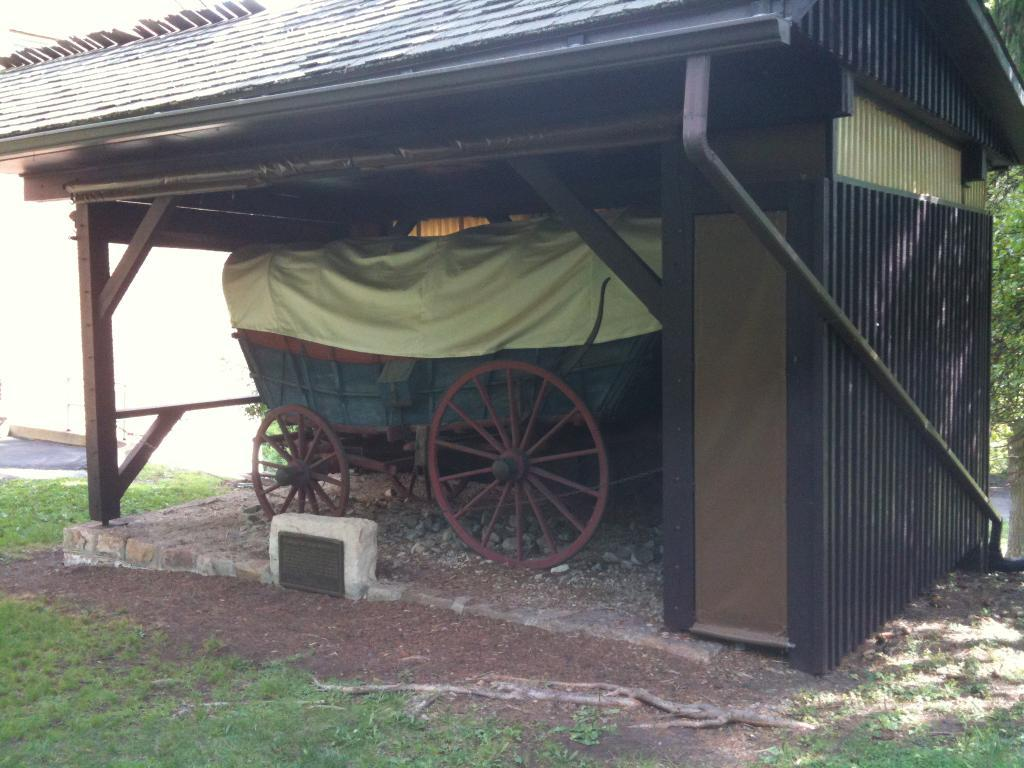What is the main structure in the center of the image? There is a shelter in the center of the image. What is located under the shelter? There is a cart under the shelter. What type of vegetation is present on the ground in the front of the image? Grass is present on the ground in the front of the image. What can be seen in the background of the image? Leaves are visible in the background of the image. How does the shelter control the attraction of the cart? The shelter does not control the attraction of the cart; it simply provides shelter for the cart. 